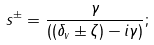<formula> <loc_0><loc_0><loc_500><loc_500>s ^ { \pm } = \frac { \gamma } { { ( } ( \delta _ { v } \pm \zeta ) - i \gamma { ) } } ;</formula> 